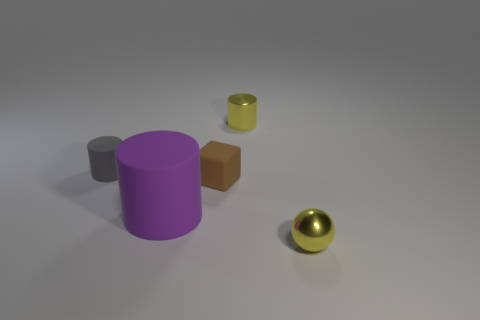What number of tiny shiny objects are the same color as the metal sphere?
Offer a very short reply. 1. Is the large matte thing the same shape as the small gray object?
Provide a succinct answer. Yes. There is a yellow object that is the same shape as the small gray matte object; what is its material?
Your response must be concise. Metal. There is a small gray thing; does it have the same shape as the small shiny object on the left side of the tiny yellow metallic sphere?
Your answer should be compact. Yes. There is a gray rubber object that is left of the tiny yellow cylinder; is its shape the same as the big object?
Keep it short and to the point. Yes. Do the metal cylinder and the matte cylinder on the right side of the tiny gray matte cylinder have the same color?
Offer a terse response. No. What number of brown things are small cubes or tiny rubber cylinders?
Offer a very short reply. 1. Are there the same number of small yellow cylinders that are behind the metal cylinder and purple rubber objects?
Provide a succinct answer. No. Are there any other things that have the same size as the purple matte thing?
Provide a short and direct response. No. There is another small object that is the same shape as the gray rubber thing; what color is it?
Offer a very short reply. Yellow. 